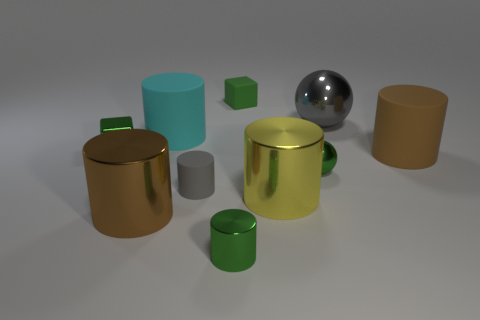What number of things are either small matte things left of the green matte thing or large brown rubber cubes?
Offer a terse response. 1. There is a gray thing in front of the object on the right side of the big metal ball; how many metallic cylinders are left of it?
Offer a very short reply. 1. There is a green thing left of the big cyan cylinder behind the big thing that is right of the large metallic ball; what shape is it?
Offer a terse response. Cube. How many other objects are there of the same color as the small shiny ball?
Offer a terse response. 3. What is the shape of the green object that is in front of the small object that is to the right of the big yellow object?
Give a very brief answer. Cylinder. There is a cyan thing; what number of tiny gray things are behind it?
Your response must be concise. 0. Are there any yellow objects made of the same material as the large gray object?
Give a very brief answer. Yes. There is a yellow object that is the same size as the cyan thing; what is it made of?
Make the answer very short. Metal. How big is the metallic thing that is both behind the small gray rubber cylinder and left of the gray rubber cylinder?
Your answer should be compact. Small. There is a thing that is on the left side of the large yellow metallic cylinder and right of the tiny green shiny cylinder; what color is it?
Give a very brief answer. Green. 